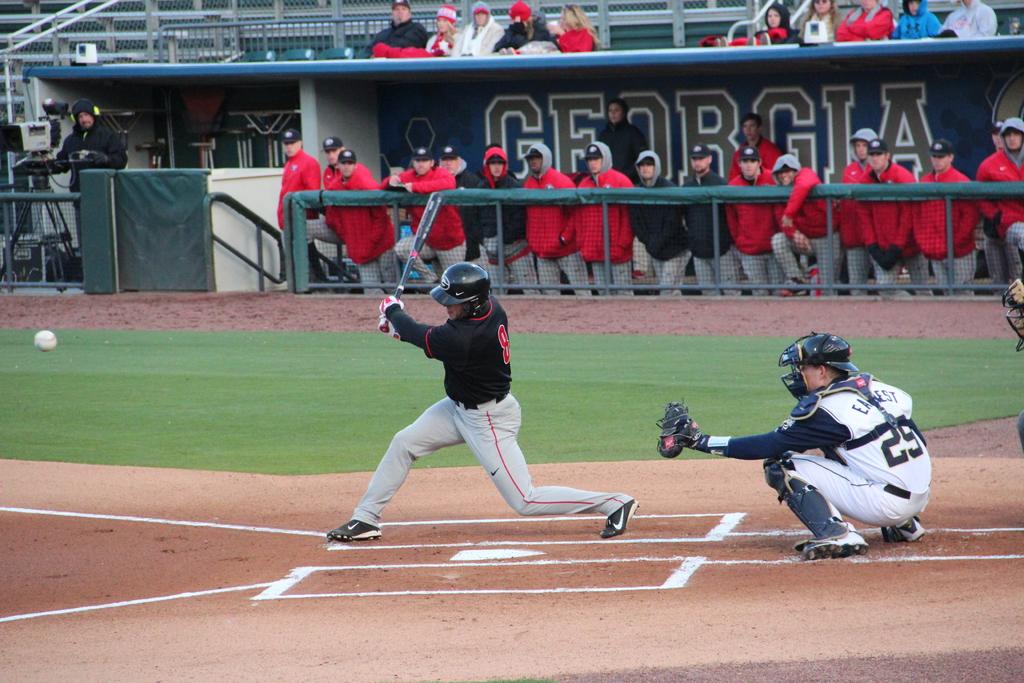What is the number on the player on the right?
Give a very brief answer. 29. 